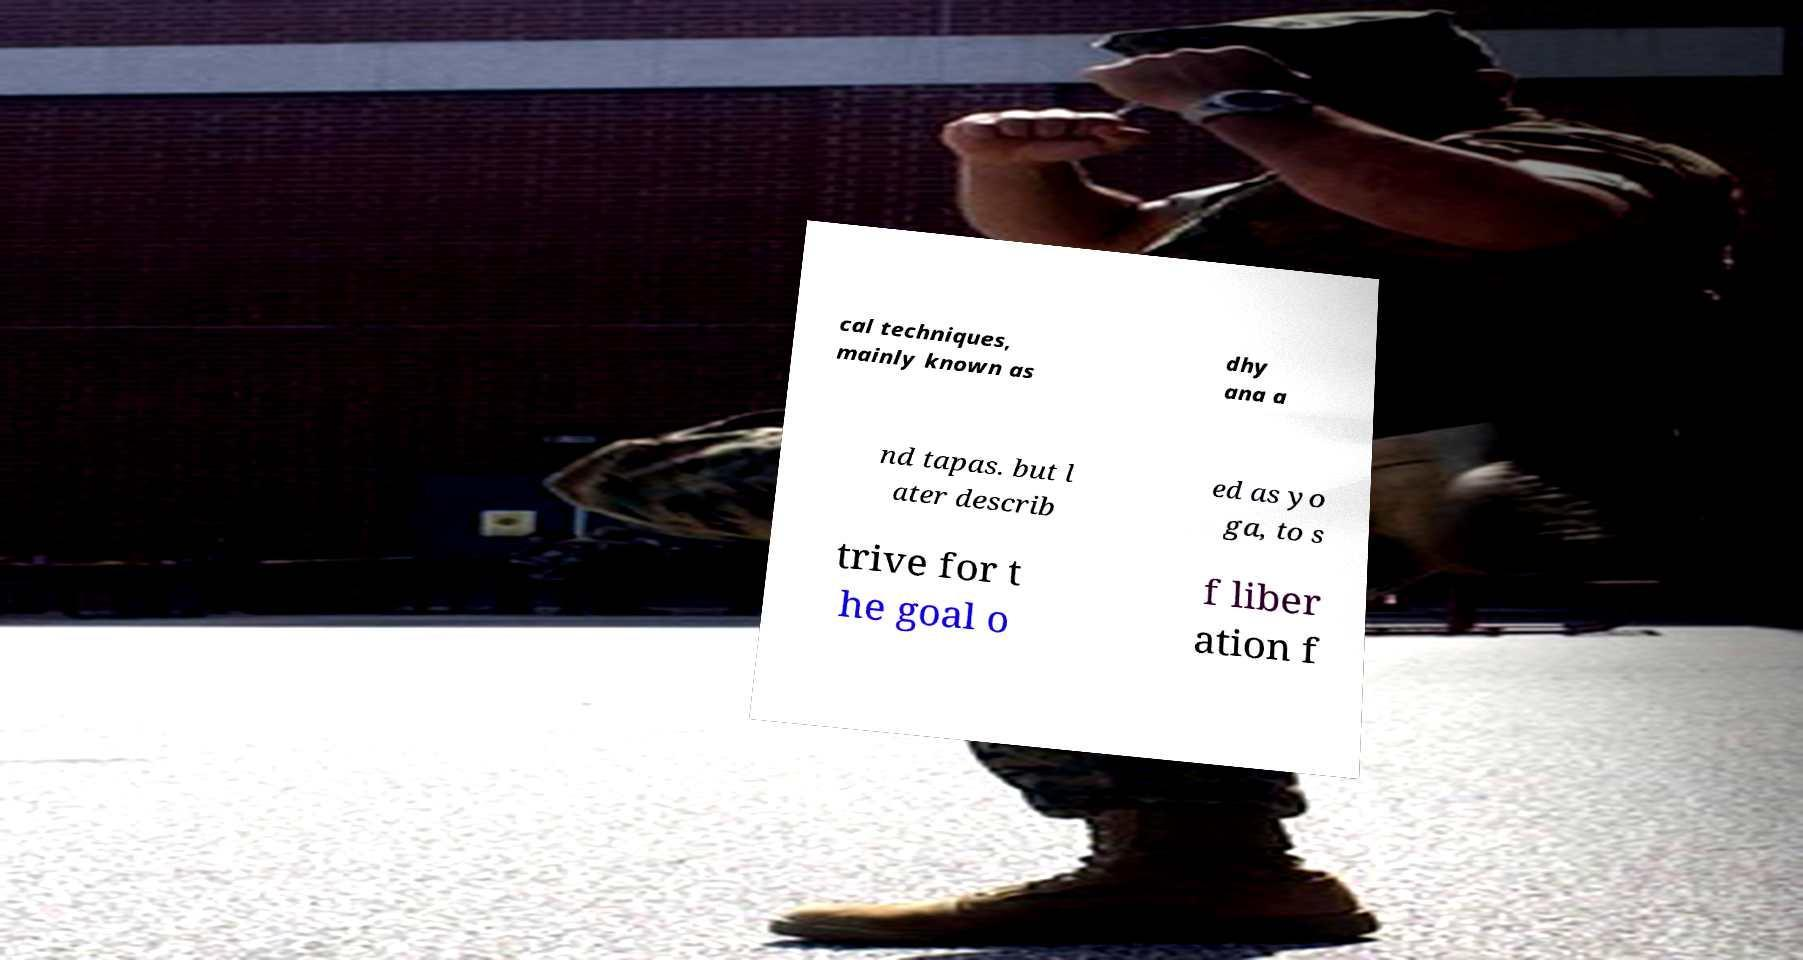Could you extract and type out the text from this image? cal techniques, mainly known as dhy ana a nd tapas. but l ater describ ed as yo ga, to s trive for t he goal o f liber ation f 